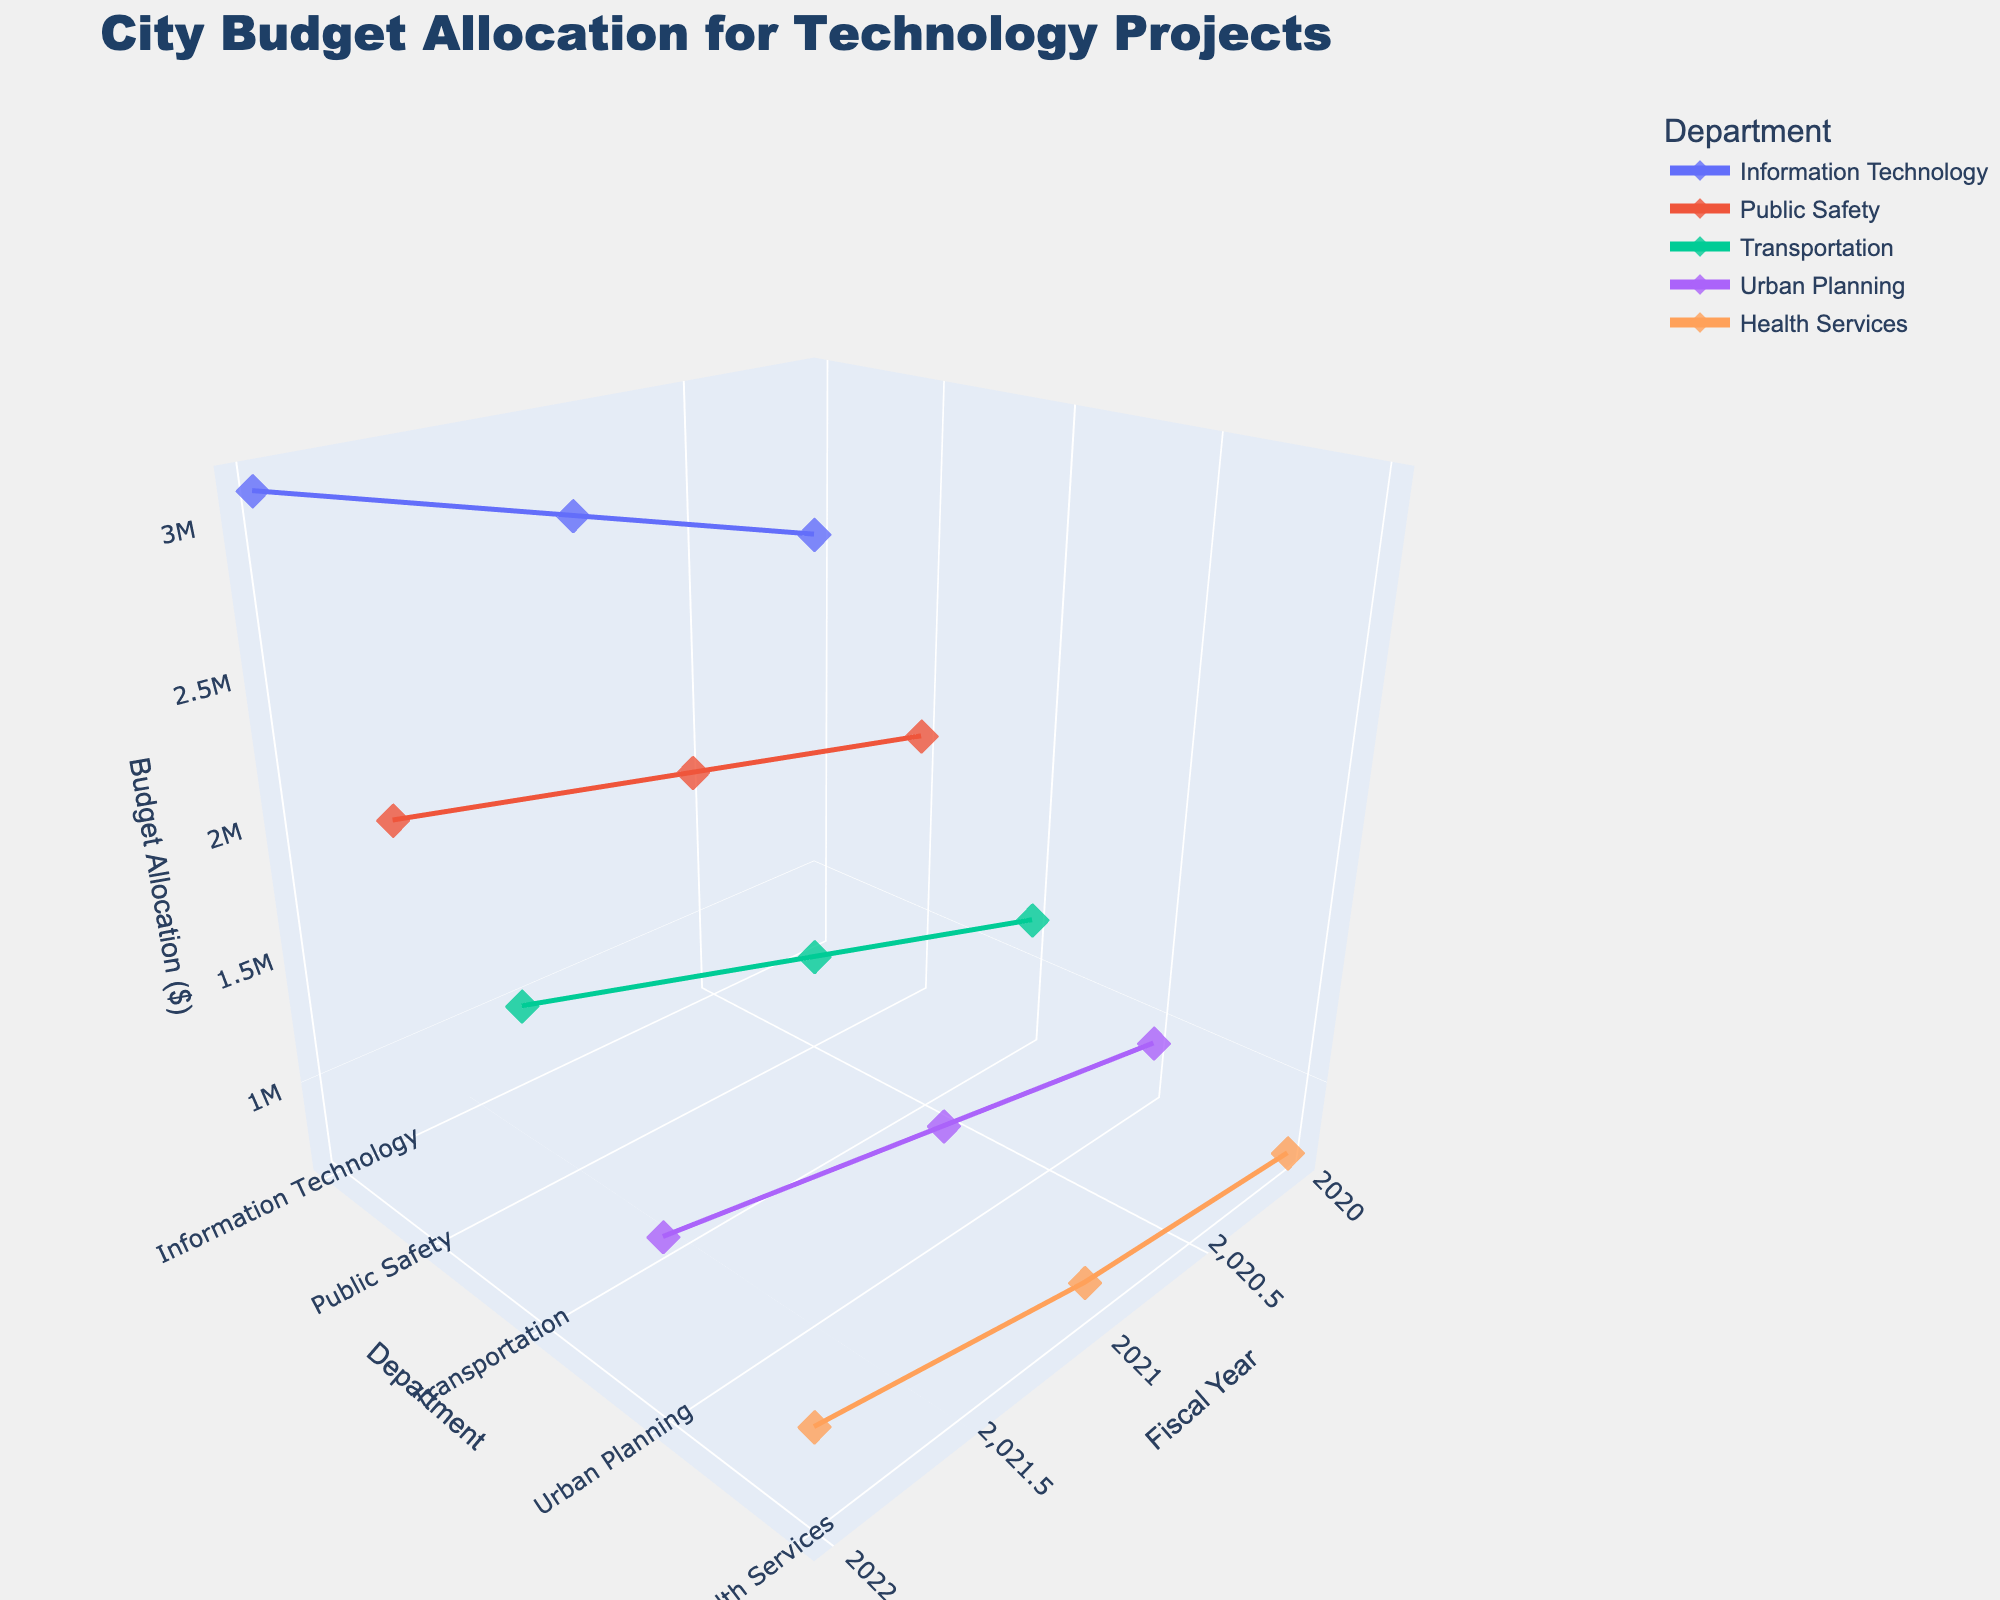What is the title of the 3D plot? The title of a plot is usually displayed at the top of the figure, providing an overview of what the data represents. According to the code provided, the title should describe the scope and aim of the data visualization.
Answer: City Budget Allocation for Technology Projects What is the range of Fiscal Years displayed on the x-axis? The x-axis represents the Fiscal Year, ranging from the earliest to the latest year covered in the dataset. By visually identifying the x-axis boundaries, we can see the range of years.
Answer: 2020 to 2022 Which department had the highest budget allocation in the year 2022? To find the highest budget allocation for 2022, locate the coordinates on the plot where the z-values (Budget Allocation) are maximum for the year 2022 (x-axis). Each department is on the y-axis.
Answer: Information Technology How does the budget allocation for Public Safety change from 2020 to 2022? Analyze the trend line for Public Safety on the y-axis and observe the changes in z-values (Budget Allocation) across the x-axis from 2020 to 2022. The department's budget allocation increases if the trend line ascends.
Answer: It increases What is the difference in budget allocation between Urban Planning and Health Services for the year 2020? Identify the z-values (Budget Allocations) for both Urban Planning and Health Services for the year 2020 from the 3D plot. Compute the difference by subtracting the smaller value from the larger.
Answer: $200,000 Which department showed the most significant growth in budget allocation from 2020 to 2022? Evaluate each department's trend line from 2020 to 2022, noting the changes in z-values (Budget Allocation). The department with the steepest upward trend signifies the most significant growth.
Answer: Transportation What was the total budget allocation for Information Technology from 2020 to 2022? Sum the z-values (Budget Allocation) for Information Technology over all three years presented on the x-axis.
Answer: $8,400,000 How does the budget allocation in 2021 for Transportation compare to that in 2020? Identify and compare the z-values (Budget Allocation) for Transportation in both 2020 and 2021. Determine which one is higher and by how much.
Answer: It increased by $300,000 